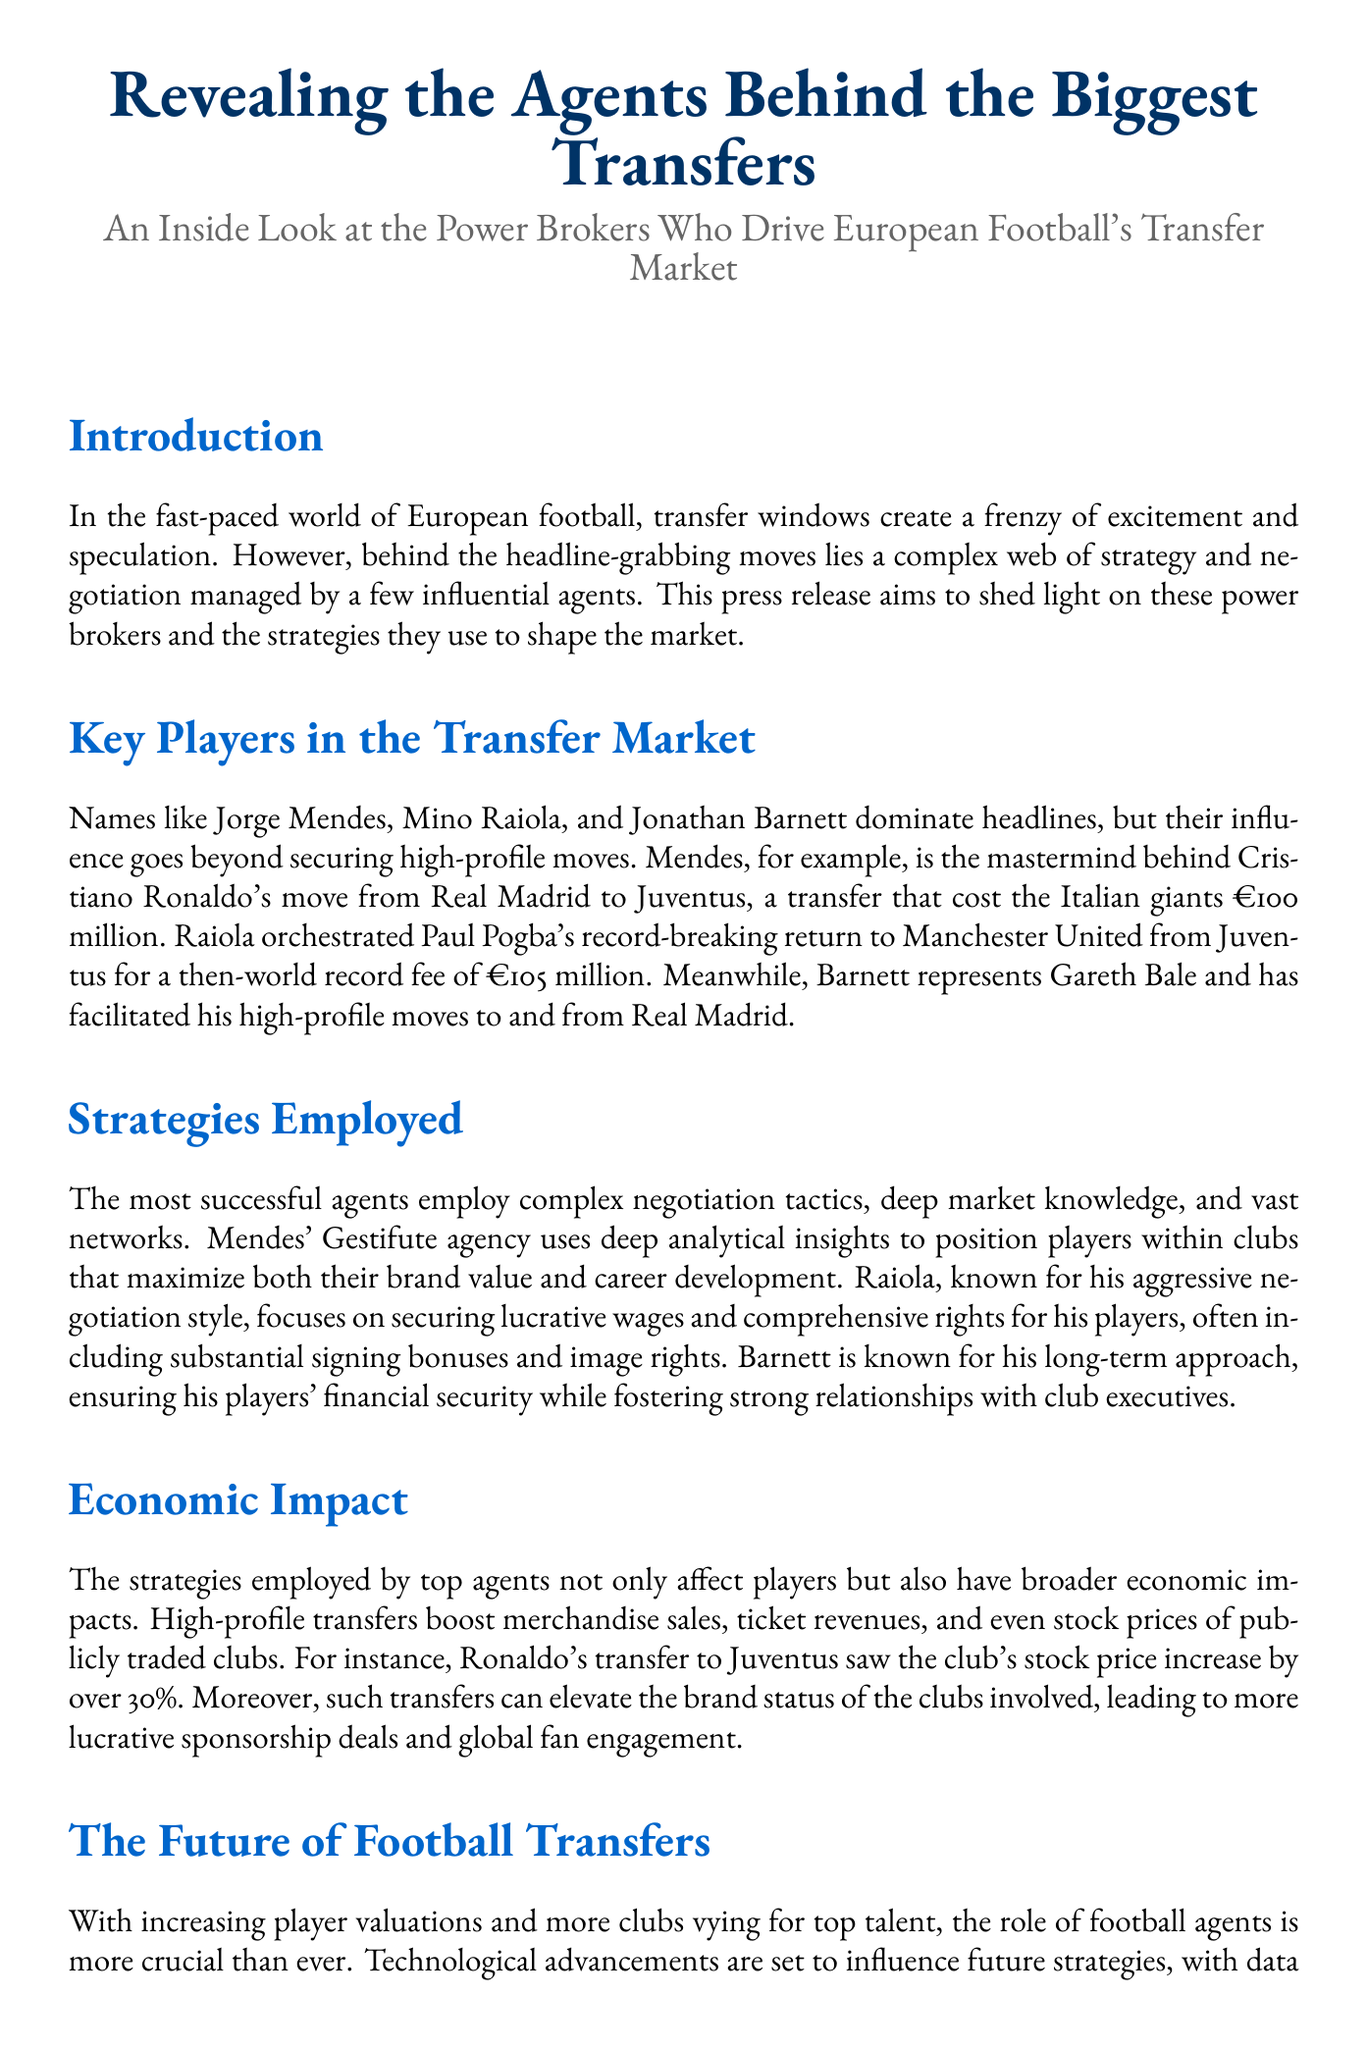What is the title of the press release? The title of the press release, as stated at the beginning, is "Revealing the Agents Behind the Biggest Transfers."
Answer: Revealing the Agents Behind the Biggest Transfers Who orchestrated Paul Pogba's transfer to Manchester United? The document states that Mino Raiola orchestrated Paul Pogba's transfer to Manchester United.
Answer: Mino Raiola What was the transfer fee for Cristiano Ronaldo's move to Juventus? The document specifies that the transfer fee for Cristiano Ronaldo's move to Juventus was €100 million.
Answer: €100 million Which agency does Jorge Mendes represent? The text mentions that Jorge Mendes is associated with the Gestifute agency.
Answer: Gestifute How much did Juventus' stock price increase after Ronaldo's transfer? The document states that Juventus' stock price increased by over 30%.
Answer: 30% What is a key characteristic of Barnett's negotiation strategy? The document describes Barnett's long-term approach as a key characteristic of his negotiation strategy.
Answer: Long-term approach What impact do high-profile transfers have on clubs' brand status? The press release notes that high-profile transfers can elevate the brand status of the clubs involved.
Answer: Elevate brand status What technological advancements are influencing the future of football transfers? The document mentions that data analytics and AI-driven insights are the advancements influencing future transfers.
Answer: Data analytics and AI-driven insights 